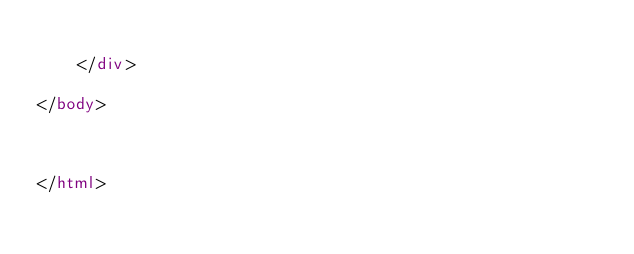Convert code to text. <code><loc_0><loc_0><loc_500><loc_500><_HTML_>	
    </div>

</body>



</html>
</code> 